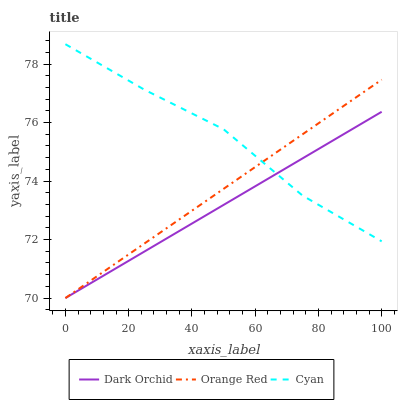Does Dark Orchid have the minimum area under the curve?
Answer yes or no. Yes. Does Cyan have the maximum area under the curve?
Answer yes or no. Yes. Does Orange Red have the minimum area under the curve?
Answer yes or no. No. Does Orange Red have the maximum area under the curve?
Answer yes or no. No. Is Orange Red the smoothest?
Answer yes or no. Yes. Is Cyan the roughest?
Answer yes or no. Yes. Is Dark Orchid the roughest?
Answer yes or no. No. Does Orange Red have the lowest value?
Answer yes or no. Yes. Does Cyan have the highest value?
Answer yes or no. Yes. Does Orange Red have the highest value?
Answer yes or no. No. Does Orange Red intersect Cyan?
Answer yes or no. Yes. Is Orange Red less than Cyan?
Answer yes or no. No. Is Orange Red greater than Cyan?
Answer yes or no. No. 